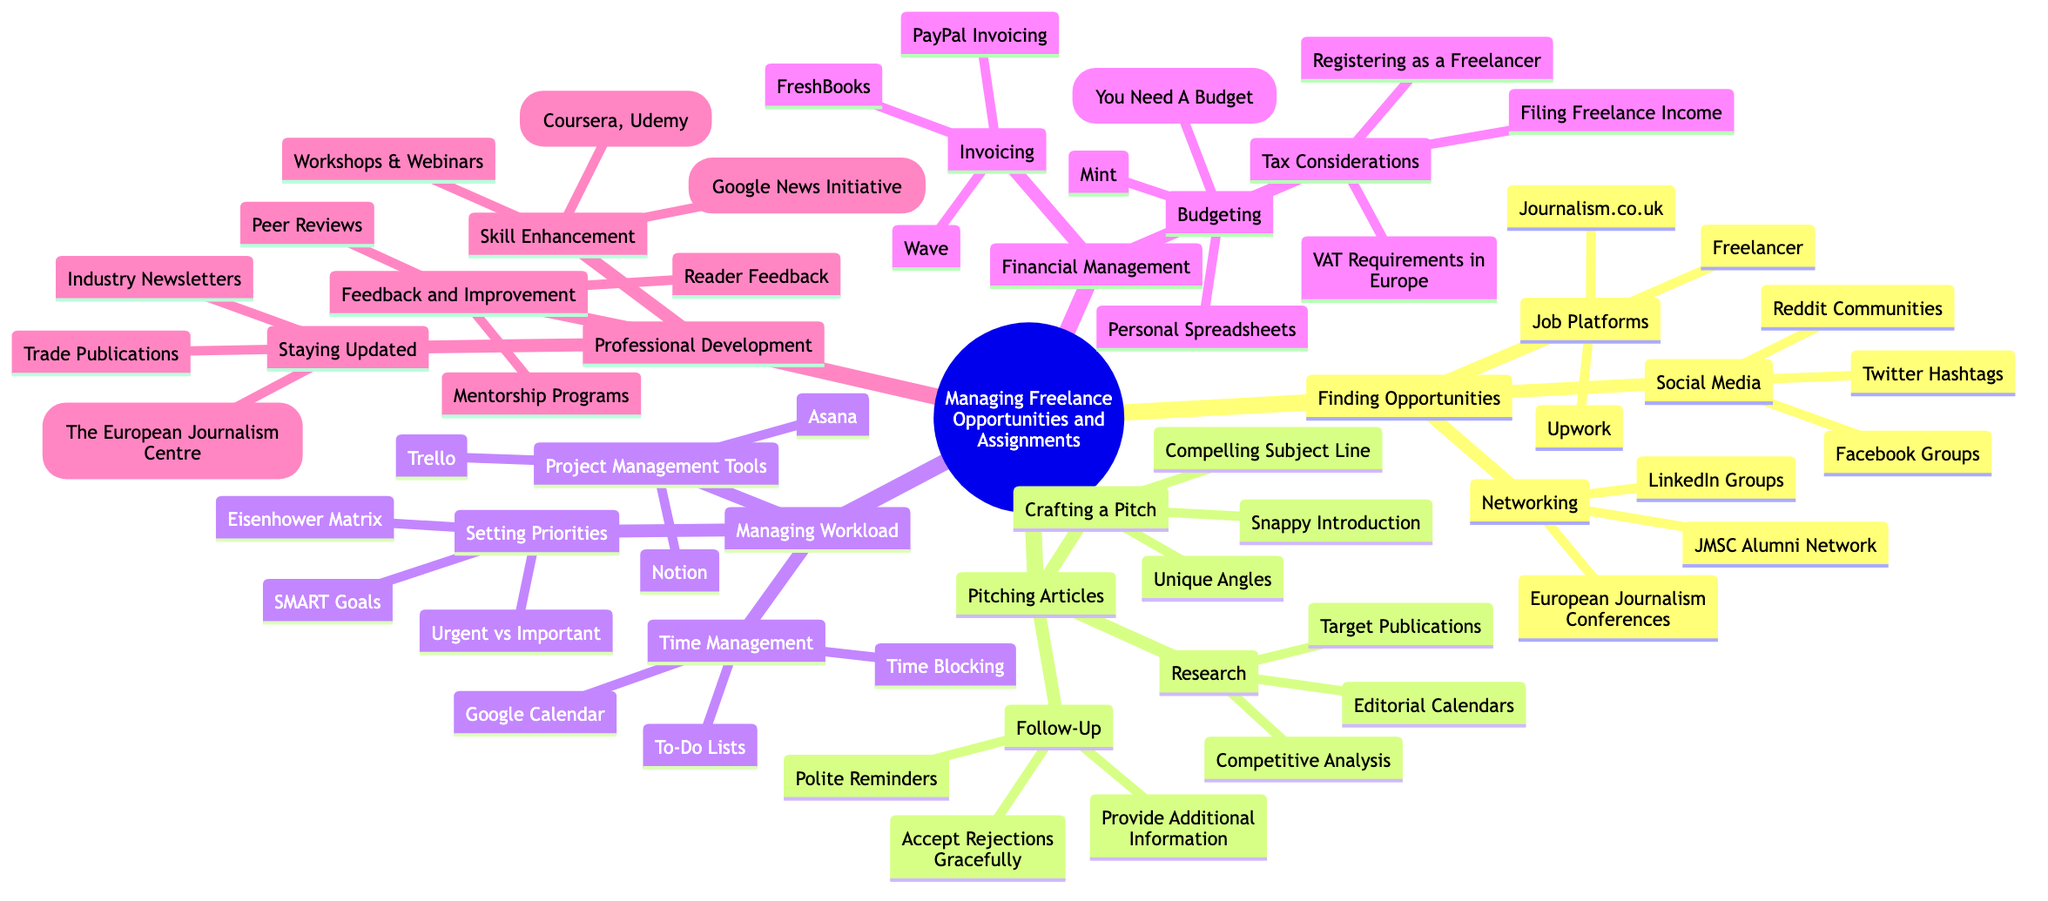What is the central topic of the mind map? The central topic is the main subject of the mind map, which in this case includes the title or focus that encompasses all other branches and sub-branches depicted in the diagram. The title is "Managing Freelance Opportunities and Assignments"
Answer: Managing Freelance Opportunities and Assignments How many main branches are there? The main branches are the primary divisions stemming from the central topic, indicating different areas of focus. Upon examination, there are five main branches: Finding Opportunities, Pitching Articles, Managing Workload, Financial Management, and Professional Development
Answer: 5 What is one of the tools listed under Project Management Tools? In the branch titled "Managing Workload," there is a sub-branch called "Project Management Tools," which includes different tools that help with project management. One of the listed tools is "Trello."
Answer: Trello What should be included in a compelling pitch according to the diagram? The sub-branch "Crafting a Pitch" includes specific elements that contribute to an effective pitch. According to the diagram, these elements include a "Compelling Subject Line," "Snappy Introduction," and "Unique Angles," which are essential for creating interest from potential clients or publications
Answer: Compelling Subject Line Which sub-branch discusses financial aspects of freelancing? The branch "Financial Management" contains sub-branches that address different financial considerations for freelancing, including invoicing, budgeting, and tax considerations. This clearly shows that the sub-branch is focused on financial aspects
Answer: Financial Management Which branch would you refer to for improving skills? The "Professional Development" branch includes sub-branches aimed at enhancing various skill sets required for freelancing, such as "Skill Enhancement," "Staying Updated," and "Feedback and Improvement." Thus, for skill enhancement, you would refer to this branch
Answer: Professional Development What is a method suggested for time management? Under the "Managing Workload" branch, specifically in the "Time Management" sub-branch, there are various methods mentioned that help in organizing time effectively. One such method is "Time Blocking," which is a recognized approach for structuring one's schedule
Answer: Time Blocking What could you use for tracking freelance income? The diagram under "Financial Management" contains a sub-branch called "Invoicing," where tools are listed that assist in managing income. One of the options for tracking freelance income is "FreshBooks"
Answer: FreshBooks Which sub-branch addresses networking? The branch "Finding Opportunities" has a sub-branch titled "Networking," which focuses on ways to connect with other professionals and find job opportunities in freelancing. Thus, this sub-branch clearly addresses the aspect of networking
Answer: Networking 